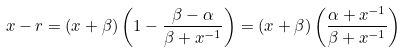<formula> <loc_0><loc_0><loc_500><loc_500>x - r = ( x + \beta ) \left ( 1 - \frac { \beta - \alpha } { \beta + x ^ { - 1 } } \right ) = ( x + \beta ) \left ( \frac { \alpha + x ^ { - 1 } } { \beta + x ^ { - 1 } } \right )</formula> 